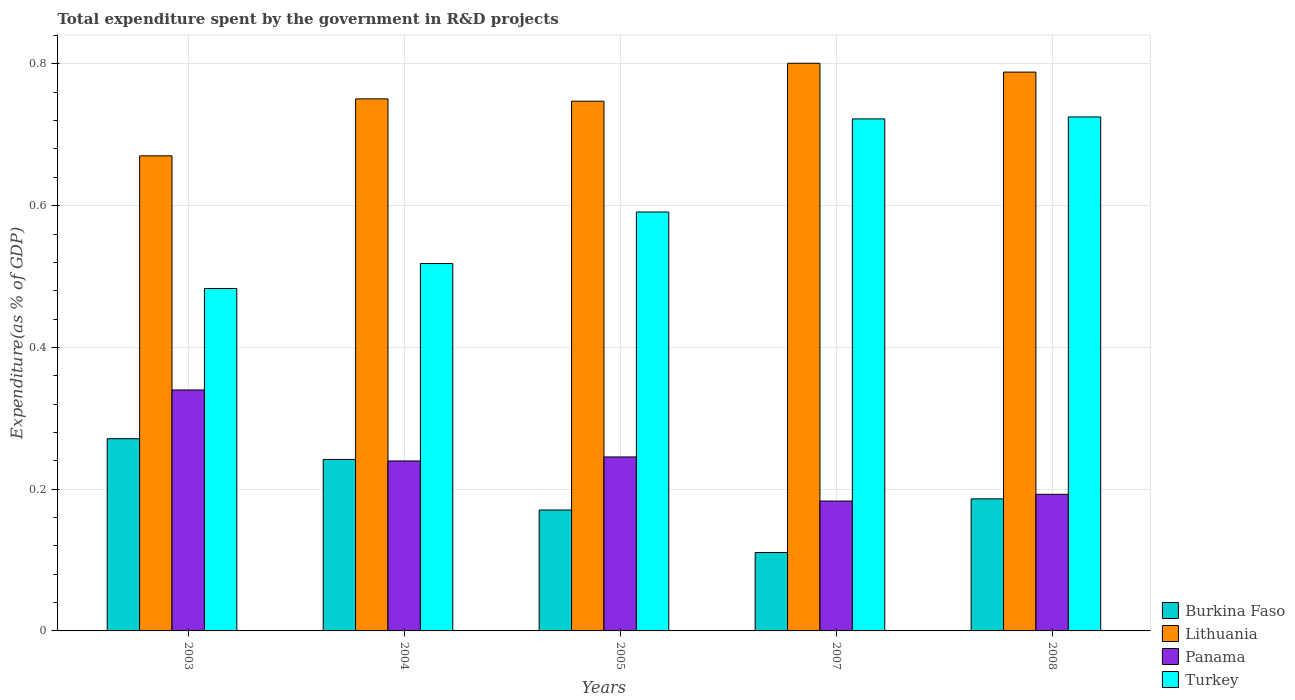How many different coloured bars are there?
Provide a short and direct response. 4. Are the number of bars per tick equal to the number of legend labels?
Make the answer very short. Yes. Are the number of bars on each tick of the X-axis equal?
Ensure brevity in your answer.  Yes. What is the label of the 4th group of bars from the left?
Your answer should be compact. 2007. In how many cases, is the number of bars for a given year not equal to the number of legend labels?
Your answer should be compact. 0. What is the total expenditure spent by the government in R&D projects in Turkey in 2007?
Your answer should be compact. 0.72. Across all years, what is the maximum total expenditure spent by the government in R&D projects in Lithuania?
Provide a short and direct response. 0.8. Across all years, what is the minimum total expenditure spent by the government in R&D projects in Panama?
Your response must be concise. 0.18. In which year was the total expenditure spent by the government in R&D projects in Turkey maximum?
Keep it short and to the point. 2008. What is the total total expenditure spent by the government in R&D projects in Lithuania in the graph?
Your answer should be very brief. 3.76. What is the difference between the total expenditure spent by the government in R&D projects in Burkina Faso in 2005 and that in 2007?
Ensure brevity in your answer.  0.06. What is the difference between the total expenditure spent by the government in R&D projects in Turkey in 2007 and the total expenditure spent by the government in R&D projects in Burkina Faso in 2005?
Offer a very short reply. 0.55. What is the average total expenditure spent by the government in R&D projects in Panama per year?
Your answer should be compact. 0.24. In the year 2005, what is the difference between the total expenditure spent by the government in R&D projects in Lithuania and total expenditure spent by the government in R&D projects in Burkina Faso?
Your answer should be very brief. 0.58. In how many years, is the total expenditure spent by the government in R&D projects in Turkey greater than 0.68 %?
Ensure brevity in your answer.  2. What is the ratio of the total expenditure spent by the government in R&D projects in Turkey in 2003 to that in 2004?
Your answer should be compact. 0.93. Is the total expenditure spent by the government in R&D projects in Turkey in 2005 less than that in 2007?
Keep it short and to the point. Yes. Is the difference between the total expenditure spent by the government in R&D projects in Lithuania in 2003 and 2005 greater than the difference between the total expenditure spent by the government in R&D projects in Burkina Faso in 2003 and 2005?
Keep it short and to the point. No. What is the difference between the highest and the second highest total expenditure spent by the government in R&D projects in Lithuania?
Offer a very short reply. 0.01. What is the difference between the highest and the lowest total expenditure spent by the government in R&D projects in Panama?
Offer a very short reply. 0.16. In how many years, is the total expenditure spent by the government in R&D projects in Turkey greater than the average total expenditure spent by the government in R&D projects in Turkey taken over all years?
Offer a very short reply. 2. Is the sum of the total expenditure spent by the government in R&D projects in Panama in 2003 and 2008 greater than the maximum total expenditure spent by the government in R&D projects in Turkey across all years?
Your answer should be compact. No. Is it the case that in every year, the sum of the total expenditure spent by the government in R&D projects in Turkey and total expenditure spent by the government in R&D projects in Burkina Faso is greater than the sum of total expenditure spent by the government in R&D projects in Lithuania and total expenditure spent by the government in R&D projects in Panama?
Keep it short and to the point. Yes. What does the 3rd bar from the left in 2003 represents?
Provide a succinct answer. Panama. What does the 1st bar from the right in 2008 represents?
Make the answer very short. Turkey. Is it the case that in every year, the sum of the total expenditure spent by the government in R&D projects in Turkey and total expenditure spent by the government in R&D projects in Lithuania is greater than the total expenditure spent by the government in R&D projects in Panama?
Your answer should be very brief. Yes. How many bars are there?
Give a very brief answer. 20. Are all the bars in the graph horizontal?
Give a very brief answer. No. Does the graph contain any zero values?
Give a very brief answer. No. Where does the legend appear in the graph?
Your answer should be very brief. Bottom right. How many legend labels are there?
Keep it short and to the point. 4. How are the legend labels stacked?
Offer a very short reply. Vertical. What is the title of the graph?
Keep it short and to the point. Total expenditure spent by the government in R&D projects. Does "Fragile and conflict affected situations" appear as one of the legend labels in the graph?
Offer a terse response. No. What is the label or title of the Y-axis?
Your answer should be compact. Expenditure(as % of GDP). What is the Expenditure(as % of GDP) of Burkina Faso in 2003?
Ensure brevity in your answer.  0.27. What is the Expenditure(as % of GDP) in Lithuania in 2003?
Give a very brief answer. 0.67. What is the Expenditure(as % of GDP) in Panama in 2003?
Keep it short and to the point. 0.34. What is the Expenditure(as % of GDP) in Turkey in 2003?
Keep it short and to the point. 0.48. What is the Expenditure(as % of GDP) of Burkina Faso in 2004?
Offer a very short reply. 0.24. What is the Expenditure(as % of GDP) in Lithuania in 2004?
Keep it short and to the point. 0.75. What is the Expenditure(as % of GDP) in Panama in 2004?
Your response must be concise. 0.24. What is the Expenditure(as % of GDP) of Turkey in 2004?
Provide a short and direct response. 0.52. What is the Expenditure(as % of GDP) in Burkina Faso in 2005?
Your response must be concise. 0.17. What is the Expenditure(as % of GDP) of Lithuania in 2005?
Ensure brevity in your answer.  0.75. What is the Expenditure(as % of GDP) of Panama in 2005?
Your answer should be very brief. 0.25. What is the Expenditure(as % of GDP) of Turkey in 2005?
Ensure brevity in your answer.  0.59. What is the Expenditure(as % of GDP) in Burkina Faso in 2007?
Your response must be concise. 0.11. What is the Expenditure(as % of GDP) of Lithuania in 2007?
Provide a short and direct response. 0.8. What is the Expenditure(as % of GDP) in Panama in 2007?
Ensure brevity in your answer.  0.18. What is the Expenditure(as % of GDP) in Turkey in 2007?
Offer a terse response. 0.72. What is the Expenditure(as % of GDP) in Burkina Faso in 2008?
Give a very brief answer. 0.19. What is the Expenditure(as % of GDP) in Lithuania in 2008?
Your answer should be very brief. 0.79. What is the Expenditure(as % of GDP) of Panama in 2008?
Provide a short and direct response. 0.19. What is the Expenditure(as % of GDP) in Turkey in 2008?
Provide a succinct answer. 0.73. Across all years, what is the maximum Expenditure(as % of GDP) in Burkina Faso?
Give a very brief answer. 0.27. Across all years, what is the maximum Expenditure(as % of GDP) of Lithuania?
Make the answer very short. 0.8. Across all years, what is the maximum Expenditure(as % of GDP) in Panama?
Offer a very short reply. 0.34. Across all years, what is the maximum Expenditure(as % of GDP) in Turkey?
Offer a very short reply. 0.73. Across all years, what is the minimum Expenditure(as % of GDP) of Burkina Faso?
Provide a succinct answer. 0.11. Across all years, what is the minimum Expenditure(as % of GDP) of Lithuania?
Ensure brevity in your answer.  0.67. Across all years, what is the minimum Expenditure(as % of GDP) of Panama?
Your answer should be very brief. 0.18. Across all years, what is the minimum Expenditure(as % of GDP) of Turkey?
Provide a short and direct response. 0.48. What is the total Expenditure(as % of GDP) of Burkina Faso in the graph?
Your answer should be very brief. 0.98. What is the total Expenditure(as % of GDP) in Lithuania in the graph?
Your answer should be compact. 3.76. What is the total Expenditure(as % of GDP) in Panama in the graph?
Offer a very short reply. 1.2. What is the total Expenditure(as % of GDP) of Turkey in the graph?
Offer a terse response. 3.04. What is the difference between the Expenditure(as % of GDP) in Burkina Faso in 2003 and that in 2004?
Your response must be concise. 0.03. What is the difference between the Expenditure(as % of GDP) of Lithuania in 2003 and that in 2004?
Your answer should be compact. -0.08. What is the difference between the Expenditure(as % of GDP) in Panama in 2003 and that in 2004?
Give a very brief answer. 0.1. What is the difference between the Expenditure(as % of GDP) in Turkey in 2003 and that in 2004?
Offer a terse response. -0.04. What is the difference between the Expenditure(as % of GDP) of Burkina Faso in 2003 and that in 2005?
Provide a succinct answer. 0.1. What is the difference between the Expenditure(as % of GDP) in Lithuania in 2003 and that in 2005?
Ensure brevity in your answer.  -0.08. What is the difference between the Expenditure(as % of GDP) of Panama in 2003 and that in 2005?
Provide a short and direct response. 0.09. What is the difference between the Expenditure(as % of GDP) of Turkey in 2003 and that in 2005?
Your answer should be compact. -0.11. What is the difference between the Expenditure(as % of GDP) of Burkina Faso in 2003 and that in 2007?
Ensure brevity in your answer.  0.16. What is the difference between the Expenditure(as % of GDP) of Lithuania in 2003 and that in 2007?
Offer a very short reply. -0.13. What is the difference between the Expenditure(as % of GDP) in Panama in 2003 and that in 2007?
Provide a short and direct response. 0.16. What is the difference between the Expenditure(as % of GDP) in Turkey in 2003 and that in 2007?
Offer a very short reply. -0.24. What is the difference between the Expenditure(as % of GDP) of Burkina Faso in 2003 and that in 2008?
Your answer should be compact. 0.08. What is the difference between the Expenditure(as % of GDP) in Lithuania in 2003 and that in 2008?
Ensure brevity in your answer.  -0.12. What is the difference between the Expenditure(as % of GDP) in Panama in 2003 and that in 2008?
Your response must be concise. 0.15. What is the difference between the Expenditure(as % of GDP) in Turkey in 2003 and that in 2008?
Provide a succinct answer. -0.24. What is the difference between the Expenditure(as % of GDP) of Burkina Faso in 2004 and that in 2005?
Give a very brief answer. 0.07. What is the difference between the Expenditure(as % of GDP) of Lithuania in 2004 and that in 2005?
Provide a short and direct response. 0. What is the difference between the Expenditure(as % of GDP) in Panama in 2004 and that in 2005?
Your answer should be very brief. -0.01. What is the difference between the Expenditure(as % of GDP) of Turkey in 2004 and that in 2005?
Make the answer very short. -0.07. What is the difference between the Expenditure(as % of GDP) in Burkina Faso in 2004 and that in 2007?
Your answer should be very brief. 0.13. What is the difference between the Expenditure(as % of GDP) of Lithuania in 2004 and that in 2007?
Your answer should be very brief. -0.05. What is the difference between the Expenditure(as % of GDP) in Panama in 2004 and that in 2007?
Keep it short and to the point. 0.06. What is the difference between the Expenditure(as % of GDP) of Turkey in 2004 and that in 2007?
Give a very brief answer. -0.2. What is the difference between the Expenditure(as % of GDP) in Burkina Faso in 2004 and that in 2008?
Offer a very short reply. 0.06. What is the difference between the Expenditure(as % of GDP) in Lithuania in 2004 and that in 2008?
Your answer should be compact. -0.04. What is the difference between the Expenditure(as % of GDP) of Panama in 2004 and that in 2008?
Your answer should be very brief. 0.05. What is the difference between the Expenditure(as % of GDP) in Turkey in 2004 and that in 2008?
Make the answer very short. -0.21. What is the difference between the Expenditure(as % of GDP) of Lithuania in 2005 and that in 2007?
Offer a terse response. -0.05. What is the difference between the Expenditure(as % of GDP) of Panama in 2005 and that in 2007?
Offer a terse response. 0.06. What is the difference between the Expenditure(as % of GDP) in Turkey in 2005 and that in 2007?
Your answer should be compact. -0.13. What is the difference between the Expenditure(as % of GDP) of Burkina Faso in 2005 and that in 2008?
Keep it short and to the point. -0.02. What is the difference between the Expenditure(as % of GDP) of Lithuania in 2005 and that in 2008?
Ensure brevity in your answer.  -0.04. What is the difference between the Expenditure(as % of GDP) of Panama in 2005 and that in 2008?
Keep it short and to the point. 0.05. What is the difference between the Expenditure(as % of GDP) in Turkey in 2005 and that in 2008?
Provide a short and direct response. -0.13. What is the difference between the Expenditure(as % of GDP) of Burkina Faso in 2007 and that in 2008?
Provide a succinct answer. -0.08. What is the difference between the Expenditure(as % of GDP) in Lithuania in 2007 and that in 2008?
Offer a terse response. 0.01. What is the difference between the Expenditure(as % of GDP) in Panama in 2007 and that in 2008?
Your response must be concise. -0.01. What is the difference between the Expenditure(as % of GDP) of Turkey in 2007 and that in 2008?
Your answer should be compact. -0. What is the difference between the Expenditure(as % of GDP) of Burkina Faso in 2003 and the Expenditure(as % of GDP) of Lithuania in 2004?
Your answer should be compact. -0.48. What is the difference between the Expenditure(as % of GDP) of Burkina Faso in 2003 and the Expenditure(as % of GDP) of Panama in 2004?
Your response must be concise. 0.03. What is the difference between the Expenditure(as % of GDP) of Burkina Faso in 2003 and the Expenditure(as % of GDP) of Turkey in 2004?
Offer a terse response. -0.25. What is the difference between the Expenditure(as % of GDP) of Lithuania in 2003 and the Expenditure(as % of GDP) of Panama in 2004?
Your answer should be very brief. 0.43. What is the difference between the Expenditure(as % of GDP) of Lithuania in 2003 and the Expenditure(as % of GDP) of Turkey in 2004?
Offer a very short reply. 0.15. What is the difference between the Expenditure(as % of GDP) of Panama in 2003 and the Expenditure(as % of GDP) of Turkey in 2004?
Offer a terse response. -0.18. What is the difference between the Expenditure(as % of GDP) in Burkina Faso in 2003 and the Expenditure(as % of GDP) in Lithuania in 2005?
Provide a succinct answer. -0.48. What is the difference between the Expenditure(as % of GDP) in Burkina Faso in 2003 and the Expenditure(as % of GDP) in Panama in 2005?
Offer a terse response. 0.03. What is the difference between the Expenditure(as % of GDP) of Burkina Faso in 2003 and the Expenditure(as % of GDP) of Turkey in 2005?
Give a very brief answer. -0.32. What is the difference between the Expenditure(as % of GDP) in Lithuania in 2003 and the Expenditure(as % of GDP) in Panama in 2005?
Provide a succinct answer. 0.42. What is the difference between the Expenditure(as % of GDP) of Lithuania in 2003 and the Expenditure(as % of GDP) of Turkey in 2005?
Your answer should be very brief. 0.08. What is the difference between the Expenditure(as % of GDP) in Panama in 2003 and the Expenditure(as % of GDP) in Turkey in 2005?
Ensure brevity in your answer.  -0.25. What is the difference between the Expenditure(as % of GDP) in Burkina Faso in 2003 and the Expenditure(as % of GDP) in Lithuania in 2007?
Ensure brevity in your answer.  -0.53. What is the difference between the Expenditure(as % of GDP) of Burkina Faso in 2003 and the Expenditure(as % of GDP) of Panama in 2007?
Your response must be concise. 0.09. What is the difference between the Expenditure(as % of GDP) of Burkina Faso in 2003 and the Expenditure(as % of GDP) of Turkey in 2007?
Provide a short and direct response. -0.45. What is the difference between the Expenditure(as % of GDP) of Lithuania in 2003 and the Expenditure(as % of GDP) of Panama in 2007?
Your answer should be very brief. 0.49. What is the difference between the Expenditure(as % of GDP) of Lithuania in 2003 and the Expenditure(as % of GDP) of Turkey in 2007?
Keep it short and to the point. -0.05. What is the difference between the Expenditure(as % of GDP) in Panama in 2003 and the Expenditure(as % of GDP) in Turkey in 2007?
Offer a terse response. -0.38. What is the difference between the Expenditure(as % of GDP) of Burkina Faso in 2003 and the Expenditure(as % of GDP) of Lithuania in 2008?
Your response must be concise. -0.52. What is the difference between the Expenditure(as % of GDP) of Burkina Faso in 2003 and the Expenditure(as % of GDP) of Panama in 2008?
Provide a succinct answer. 0.08. What is the difference between the Expenditure(as % of GDP) in Burkina Faso in 2003 and the Expenditure(as % of GDP) in Turkey in 2008?
Ensure brevity in your answer.  -0.45. What is the difference between the Expenditure(as % of GDP) in Lithuania in 2003 and the Expenditure(as % of GDP) in Panama in 2008?
Provide a short and direct response. 0.48. What is the difference between the Expenditure(as % of GDP) in Lithuania in 2003 and the Expenditure(as % of GDP) in Turkey in 2008?
Your answer should be compact. -0.05. What is the difference between the Expenditure(as % of GDP) in Panama in 2003 and the Expenditure(as % of GDP) in Turkey in 2008?
Your response must be concise. -0.39. What is the difference between the Expenditure(as % of GDP) of Burkina Faso in 2004 and the Expenditure(as % of GDP) of Lithuania in 2005?
Keep it short and to the point. -0.51. What is the difference between the Expenditure(as % of GDP) in Burkina Faso in 2004 and the Expenditure(as % of GDP) in Panama in 2005?
Ensure brevity in your answer.  -0. What is the difference between the Expenditure(as % of GDP) of Burkina Faso in 2004 and the Expenditure(as % of GDP) of Turkey in 2005?
Your answer should be very brief. -0.35. What is the difference between the Expenditure(as % of GDP) in Lithuania in 2004 and the Expenditure(as % of GDP) in Panama in 2005?
Make the answer very short. 0.51. What is the difference between the Expenditure(as % of GDP) of Lithuania in 2004 and the Expenditure(as % of GDP) of Turkey in 2005?
Give a very brief answer. 0.16. What is the difference between the Expenditure(as % of GDP) of Panama in 2004 and the Expenditure(as % of GDP) of Turkey in 2005?
Make the answer very short. -0.35. What is the difference between the Expenditure(as % of GDP) in Burkina Faso in 2004 and the Expenditure(as % of GDP) in Lithuania in 2007?
Your response must be concise. -0.56. What is the difference between the Expenditure(as % of GDP) of Burkina Faso in 2004 and the Expenditure(as % of GDP) of Panama in 2007?
Your answer should be very brief. 0.06. What is the difference between the Expenditure(as % of GDP) of Burkina Faso in 2004 and the Expenditure(as % of GDP) of Turkey in 2007?
Provide a short and direct response. -0.48. What is the difference between the Expenditure(as % of GDP) of Lithuania in 2004 and the Expenditure(as % of GDP) of Panama in 2007?
Provide a short and direct response. 0.57. What is the difference between the Expenditure(as % of GDP) of Lithuania in 2004 and the Expenditure(as % of GDP) of Turkey in 2007?
Your answer should be compact. 0.03. What is the difference between the Expenditure(as % of GDP) of Panama in 2004 and the Expenditure(as % of GDP) of Turkey in 2007?
Offer a very short reply. -0.48. What is the difference between the Expenditure(as % of GDP) of Burkina Faso in 2004 and the Expenditure(as % of GDP) of Lithuania in 2008?
Offer a very short reply. -0.55. What is the difference between the Expenditure(as % of GDP) of Burkina Faso in 2004 and the Expenditure(as % of GDP) of Panama in 2008?
Make the answer very short. 0.05. What is the difference between the Expenditure(as % of GDP) in Burkina Faso in 2004 and the Expenditure(as % of GDP) in Turkey in 2008?
Provide a succinct answer. -0.48. What is the difference between the Expenditure(as % of GDP) of Lithuania in 2004 and the Expenditure(as % of GDP) of Panama in 2008?
Provide a succinct answer. 0.56. What is the difference between the Expenditure(as % of GDP) of Lithuania in 2004 and the Expenditure(as % of GDP) of Turkey in 2008?
Your response must be concise. 0.03. What is the difference between the Expenditure(as % of GDP) in Panama in 2004 and the Expenditure(as % of GDP) in Turkey in 2008?
Your answer should be compact. -0.49. What is the difference between the Expenditure(as % of GDP) of Burkina Faso in 2005 and the Expenditure(as % of GDP) of Lithuania in 2007?
Provide a succinct answer. -0.63. What is the difference between the Expenditure(as % of GDP) of Burkina Faso in 2005 and the Expenditure(as % of GDP) of Panama in 2007?
Provide a short and direct response. -0.01. What is the difference between the Expenditure(as % of GDP) of Burkina Faso in 2005 and the Expenditure(as % of GDP) of Turkey in 2007?
Offer a very short reply. -0.55. What is the difference between the Expenditure(as % of GDP) in Lithuania in 2005 and the Expenditure(as % of GDP) in Panama in 2007?
Give a very brief answer. 0.56. What is the difference between the Expenditure(as % of GDP) of Lithuania in 2005 and the Expenditure(as % of GDP) of Turkey in 2007?
Make the answer very short. 0.03. What is the difference between the Expenditure(as % of GDP) in Panama in 2005 and the Expenditure(as % of GDP) in Turkey in 2007?
Offer a very short reply. -0.48. What is the difference between the Expenditure(as % of GDP) in Burkina Faso in 2005 and the Expenditure(as % of GDP) in Lithuania in 2008?
Your response must be concise. -0.62. What is the difference between the Expenditure(as % of GDP) of Burkina Faso in 2005 and the Expenditure(as % of GDP) of Panama in 2008?
Provide a succinct answer. -0.02. What is the difference between the Expenditure(as % of GDP) of Burkina Faso in 2005 and the Expenditure(as % of GDP) of Turkey in 2008?
Ensure brevity in your answer.  -0.55. What is the difference between the Expenditure(as % of GDP) of Lithuania in 2005 and the Expenditure(as % of GDP) of Panama in 2008?
Give a very brief answer. 0.55. What is the difference between the Expenditure(as % of GDP) of Lithuania in 2005 and the Expenditure(as % of GDP) of Turkey in 2008?
Give a very brief answer. 0.02. What is the difference between the Expenditure(as % of GDP) of Panama in 2005 and the Expenditure(as % of GDP) of Turkey in 2008?
Give a very brief answer. -0.48. What is the difference between the Expenditure(as % of GDP) of Burkina Faso in 2007 and the Expenditure(as % of GDP) of Lithuania in 2008?
Your response must be concise. -0.68. What is the difference between the Expenditure(as % of GDP) in Burkina Faso in 2007 and the Expenditure(as % of GDP) in Panama in 2008?
Your answer should be compact. -0.08. What is the difference between the Expenditure(as % of GDP) in Burkina Faso in 2007 and the Expenditure(as % of GDP) in Turkey in 2008?
Make the answer very short. -0.61. What is the difference between the Expenditure(as % of GDP) in Lithuania in 2007 and the Expenditure(as % of GDP) in Panama in 2008?
Offer a terse response. 0.61. What is the difference between the Expenditure(as % of GDP) in Lithuania in 2007 and the Expenditure(as % of GDP) in Turkey in 2008?
Keep it short and to the point. 0.08. What is the difference between the Expenditure(as % of GDP) in Panama in 2007 and the Expenditure(as % of GDP) in Turkey in 2008?
Your answer should be very brief. -0.54. What is the average Expenditure(as % of GDP) of Burkina Faso per year?
Your answer should be compact. 0.2. What is the average Expenditure(as % of GDP) in Lithuania per year?
Your answer should be compact. 0.75. What is the average Expenditure(as % of GDP) in Panama per year?
Your answer should be compact. 0.24. What is the average Expenditure(as % of GDP) in Turkey per year?
Ensure brevity in your answer.  0.61. In the year 2003, what is the difference between the Expenditure(as % of GDP) of Burkina Faso and Expenditure(as % of GDP) of Lithuania?
Your answer should be compact. -0.4. In the year 2003, what is the difference between the Expenditure(as % of GDP) of Burkina Faso and Expenditure(as % of GDP) of Panama?
Give a very brief answer. -0.07. In the year 2003, what is the difference between the Expenditure(as % of GDP) of Burkina Faso and Expenditure(as % of GDP) of Turkey?
Keep it short and to the point. -0.21. In the year 2003, what is the difference between the Expenditure(as % of GDP) in Lithuania and Expenditure(as % of GDP) in Panama?
Make the answer very short. 0.33. In the year 2003, what is the difference between the Expenditure(as % of GDP) of Lithuania and Expenditure(as % of GDP) of Turkey?
Make the answer very short. 0.19. In the year 2003, what is the difference between the Expenditure(as % of GDP) of Panama and Expenditure(as % of GDP) of Turkey?
Provide a succinct answer. -0.14. In the year 2004, what is the difference between the Expenditure(as % of GDP) in Burkina Faso and Expenditure(as % of GDP) in Lithuania?
Offer a very short reply. -0.51. In the year 2004, what is the difference between the Expenditure(as % of GDP) in Burkina Faso and Expenditure(as % of GDP) in Panama?
Provide a succinct answer. 0. In the year 2004, what is the difference between the Expenditure(as % of GDP) in Burkina Faso and Expenditure(as % of GDP) in Turkey?
Offer a terse response. -0.28. In the year 2004, what is the difference between the Expenditure(as % of GDP) in Lithuania and Expenditure(as % of GDP) in Panama?
Your answer should be compact. 0.51. In the year 2004, what is the difference between the Expenditure(as % of GDP) of Lithuania and Expenditure(as % of GDP) of Turkey?
Provide a short and direct response. 0.23. In the year 2004, what is the difference between the Expenditure(as % of GDP) of Panama and Expenditure(as % of GDP) of Turkey?
Ensure brevity in your answer.  -0.28. In the year 2005, what is the difference between the Expenditure(as % of GDP) in Burkina Faso and Expenditure(as % of GDP) in Lithuania?
Offer a very short reply. -0.58. In the year 2005, what is the difference between the Expenditure(as % of GDP) of Burkina Faso and Expenditure(as % of GDP) of Panama?
Your answer should be compact. -0.07. In the year 2005, what is the difference between the Expenditure(as % of GDP) in Burkina Faso and Expenditure(as % of GDP) in Turkey?
Your response must be concise. -0.42. In the year 2005, what is the difference between the Expenditure(as % of GDP) of Lithuania and Expenditure(as % of GDP) of Panama?
Keep it short and to the point. 0.5. In the year 2005, what is the difference between the Expenditure(as % of GDP) of Lithuania and Expenditure(as % of GDP) of Turkey?
Your answer should be compact. 0.16. In the year 2005, what is the difference between the Expenditure(as % of GDP) of Panama and Expenditure(as % of GDP) of Turkey?
Provide a short and direct response. -0.35. In the year 2007, what is the difference between the Expenditure(as % of GDP) of Burkina Faso and Expenditure(as % of GDP) of Lithuania?
Provide a succinct answer. -0.69. In the year 2007, what is the difference between the Expenditure(as % of GDP) in Burkina Faso and Expenditure(as % of GDP) in Panama?
Give a very brief answer. -0.07. In the year 2007, what is the difference between the Expenditure(as % of GDP) in Burkina Faso and Expenditure(as % of GDP) in Turkey?
Your answer should be compact. -0.61. In the year 2007, what is the difference between the Expenditure(as % of GDP) of Lithuania and Expenditure(as % of GDP) of Panama?
Offer a very short reply. 0.62. In the year 2007, what is the difference between the Expenditure(as % of GDP) in Lithuania and Expenditure(as % of GDP) in Turkey?
Keep it short and to the point. 0.08. In the year 2007, what is the difference between the Expenditure(as % of GDP) of Panama and Expenditure(as % of GDP) of Turkey?
Provide a succinct answer. -0.54. In the year 2008, what is the difference between the Expenditure(as % of GDP) in Burkina Faso and Expenditure(as % of GDP) in Lithuania?
Your response must be concise. -0.6. In the year 2008, what is the difference between the Expenditure(as % of GDP) of Burkina Faso and Expenditure(as % of GDP) of Panama?
Offer a very short reply. -0.01. In the year 2008, what is the difference between the Expenditure(as % of GDP) in Burkina Faso and Expenditure(as % of GDP) in Turkey?
Give a very brief answer. -0.54. In the year 2008, what is the difference between the Expenditure(as % of GDP) of Lithuania and Expenditure(as % of GDP) of Panama?
Your answer should be very brief. 0.6. In the year 2008, what is the difference between the Expenditure(as % of GDP) in Lithuania and Expenditure(as % of GDP) in Turkey?
Ensure brevity in your answer.  0.06. In the year 2008, what is the difference between the Expenditure(as % of GDP) in Panama and Expenditure(as % of GDP) in Turkey?
Ensure brevity in your answer.  -0.53. What is the ratio of the Expenditure(as % of GDP) in Burkina Faso in 2003 to that in 2004?
Provide a short and direct response. 1.12. What is the ratio of the Expenditure(as % of GDP) in Lithuania in 2003 to that in 2004?
Make the answer very short. 0.89. What is the ratio of the Expenditure(as % of GDP) in Panama in 2003 to that in 2004?
Provide a short and direct response. 1.42. What is the ratio of the Expenditure(as % of GDP) in Turkey in 2003 to that in 2004?
Make the answer very short. 0.93. What is the ratio of the Expenditure(as % of GDP) of Burkina Faso in 2003 to that in 2005?
Your answer should be very brief. 1.59. What is the ratio of the Expenditure(as % of GDP) of Lithuania in 2003 to that in 2005?
Offer a very short reply. 0.9. What is the ratio of the Expenditure(as % of GDP) in Panama in 2003 to that in 2005?
Your answer should be very brief. 1.39. What is the ratio of the Expenditure(as % of GDP) in Turkey in 2003 to that in 2005?
Make the answer very short. 0.82. What is the ratio of the Expenditure(as % of GDP) in Burkina Faso in 2003 to that in 2007?
Make the answer very short. 2.45. What is the ratio of the Expenditure(as % of GDP) of Lithuania in 2003 to that in 2007?
Your answer should be compact. 0.84. What is the ratio of the Expenditure(as % of GDP) in Panama in 2003 to that in 2007?
Your answer should be compact. 1.86. What is the ratio of the Expenditure(as % of GDP) of Turkey in 2003 to that in 2007?
Keep it short and to the point. 0.67. What is the ratio of the Expenditure(as % of GDP) of Burkina Faso in 2003 to that in 2008?
Offer a very short reply. 1.46. What is the ratio of the Expenditure(as % of GDP) of Lithuania in 2003 to that in 2008?
Offer a terse response. 0.85. What is the ratio of the Expenditure(as % of GDP) of Panama in 2003 to that in 2008?
Offer a very short reply. 1.76. What is the ratio of the Expenditure(as % of GDP) of Turkey in 2003 to that in 2008?
Provide a succinct answer. 0.67. What is the ratio of the Expenditure(as % of GDP) of Burkina Faso in 2004 to that in 2005?
Provide a succinct answer. 1.42. What is the ratio of the Expenditure(as % of GDP) in Panama in 2004 to that in 2005?
Your response must be concise. 0.98. What is the ratio of the Expenditure(as % of GDP) of Turkey in 2004 to that in 2005?
Your answer should be compact. 0.88. What is the ratio of the Expenditure(as % of GDP) of Burkina Faso in 2004 to that in 2007?
Make the answer very short. 2.19. What is the ratio of the Expenditure(as % of GDP) in Lithuania in 2004 to that in 2007?
Give a very brief answer. 0.94. What is the ratio of the Expenditure(as % of GDP) in Panama in 2004 to that in 2007?
Provide a succinct answer. 1.31. What is the ratio of the Expenditure(as % of GDP) in Turkey in 2004 to that in 2007?
Your response must be concise. 0.72. What is the ratio of the Expenditure(as % of GDP) in Burkina Faso in 2004 to that in 2008?
Offer a very short reply. 1.3. What is the ratio of the Expenditure(as % of GDP) in Lithuania in 2004 to that in 2008?
Give a very brief answer. 0.95. What is the ratio of the Expenditure(as % of GDP) in Panama in 2004 to that in 2008?
Ensure brevity in your answer.  1.24. What is the ratio of the Expenditure(as % of GDP) in Turkey in 2004 to that in 2008?
Make the answer very short. 0.71. What is the ratio of the Expenditure(as % of GDP) of Burkina Faso in 2005 to that in 2007?
Your answer should be very brief. 1.54. What is the ratio of the Expenditure(as % of GDP) in Lithuania in 2005 to that in 2007?
Keep it short and to the point. 0.93. What is the ratio of the Expenditure(as % of GDP) of Panama in 2005 to that in 2007?
Ensure brevity in your answer.  1.34. What is the ratio of the Expenditure(as % of GDP) of Turkey in 2005 to that in 2007?
Your answer should be very brief. 0.82. What is the ratio of the Expenditure(as % of GDP) of Burkina Faso in 2005 to that in 2008?
Your answer should be very brief. 0.92. What is the ratio of the Expenditure(as % of GDP) of Lithuania in 2005 to that in 2008?
Offer a very short reply. 0.95. What is the ratio of the Expenditure(as % of GDP) of Panama in 2005 to that in 2008?
Your response must be concise. 1.27. What is the ratio of the Expenditure(as % of GDP) of Turkey in 2005 to that in 2008?
Keep it short and to the point. 0.81. What is the ratio of the Expenditure(as % of GDP) of Burkina Faso in 2007 to that in 2008?
Offer a terse response. 0.59. What is the ratio of the Expenditure(as % of GDP) of Lithuania in 2007 to that in 2008?
Your response must be concise. 1.02. What is the ratio of the Expenditure(as % of GDP) in Panama in 2007 to that in 2008?
Provide a short and direct response. 0.95. What is the ratio of the Expenditure(as % of GDP) of Turkey in 2007 to that in 2008?
Give a very brief answer. 1. What is the difference between the highest and the second highest Expenditure(as % of GDP) of Burkina Faso?
Provide a succinct answer. 0.03. What is the difference between the highest and the second highest Expenditure(as % of GDP) of Lithuania?
Your answer should be very brief. 0.01. What is the difference between the highest and the second highest Expenditure(as % of GDP) in Panama?
Make the answer very short. 0.09. What is the difference between the highest and the second highest Expenditure(as % of GDP) in Turkey?
Ensure brevity in your answer.  0. What is the difference between the highest and the lowest Expenditure(as % of GDP) of Burkina Faso?
Your answer should be compact. 0.16. What is the difference between the highest and the lowest Expenditure(as % of GDP) in Lithuania?
Your answer should be very brief. 0.13. What is the difference between the highest and the lowest Expenditure(as % of GDP) of Panama?
Your response must be concise. 0.16. What is the difference between the highest and the lowest Expenditure(as % of GDP) in Turkey?
Ensure brevity in your answer.  0.24. 